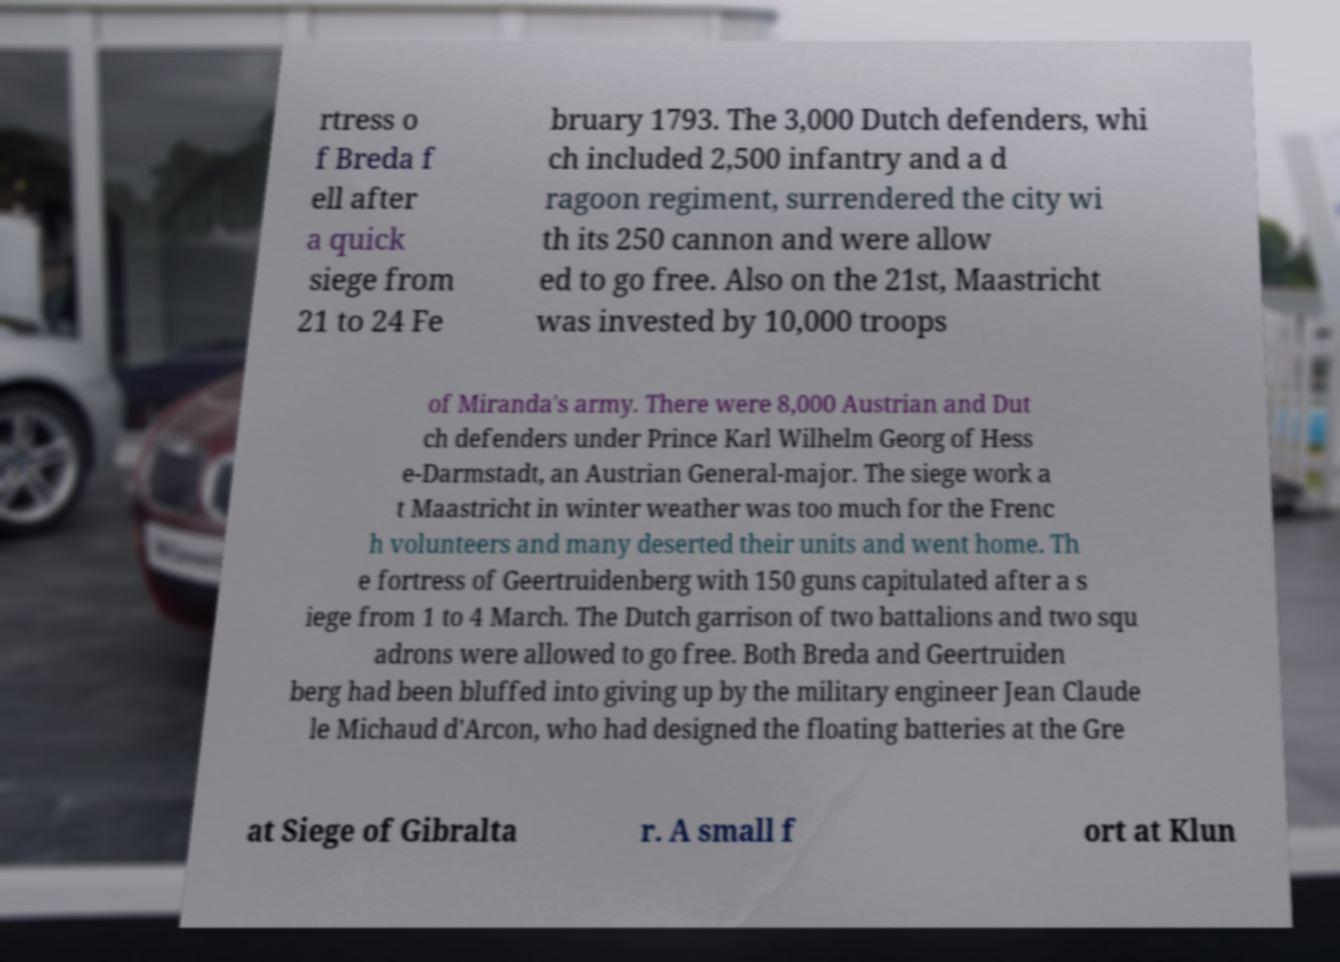What messages or text are displayed in this image? I need them in a readable, typed format. rtress o f Breda f ell after a quick siege from 21 to 24 Fe bruary 1793. The 3,000 Dutch defenders, whi ch included 2,500 infantry and a d ragoon regiment, surrendered the city wi th its 250 cannon and were allow ed to go free. Also on the 21st, Maastricht was invested by 10,000 troops of Miranda's army. There were 8,000 Austrian and Dut ch defenders under Prince Karl Wilhelm Georg of Hess e-Darmstadt, an Austrian General-major. The siege work a t Maastricht in winter weather was too much for the Frenc h volunteers and many deserted their units and went home. Th e fortress of Geertruidenberg with 150 guns capitulated after a s iege from 1 to 4 March. The Dutch garrison of two battalions and two squ adrons were allowed to go free. Both Breda and Geertruiden berg had been bluffed into giving up by the military engineer Jean Claude le Michaud d'Arcon, who had designed the floating batteries at the Gre at Siege of Gibralta r. A small f ort at Klun 